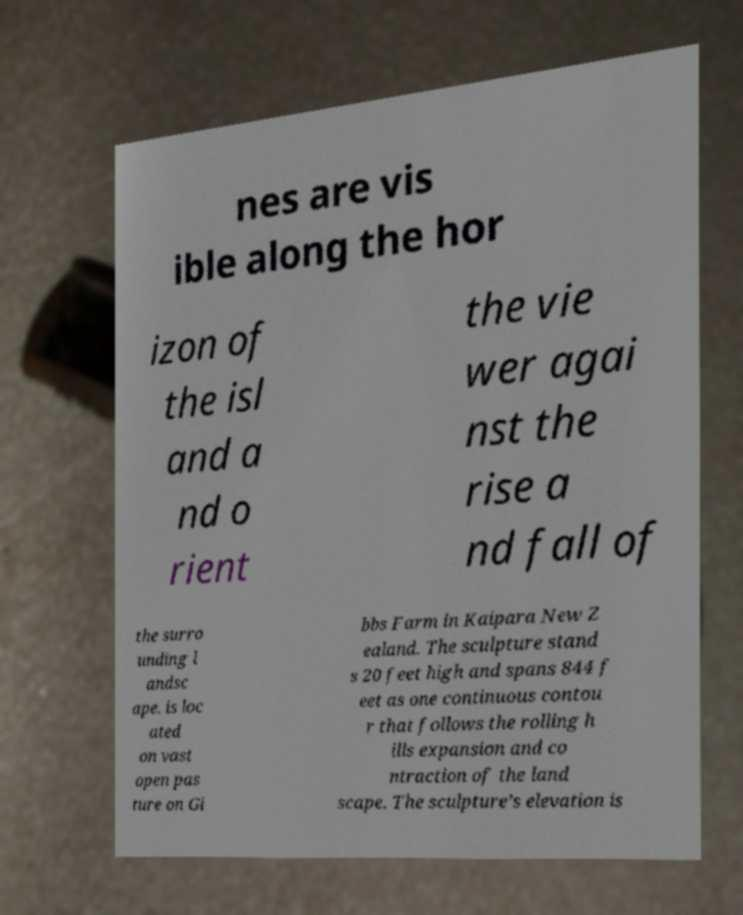Can you read and provide the text displayed in the image?This photo seems to have some interesting text. Can you extract and type it out for me? nes are vis ible along the hor izon of the isl and a nd o rient the vie wer agai nst the rise a nd fall of the surro unding l andsc ape. is loc ated on vast open pas ture on Gi bbs Farm in Kaipara New Z ealand. The sculpture stand s 20 feet high and spans 844 f eet as one continuous contou r that follows the rolling h ills expansion and co ntraction of the land scape. The sculpture’s elevation is 